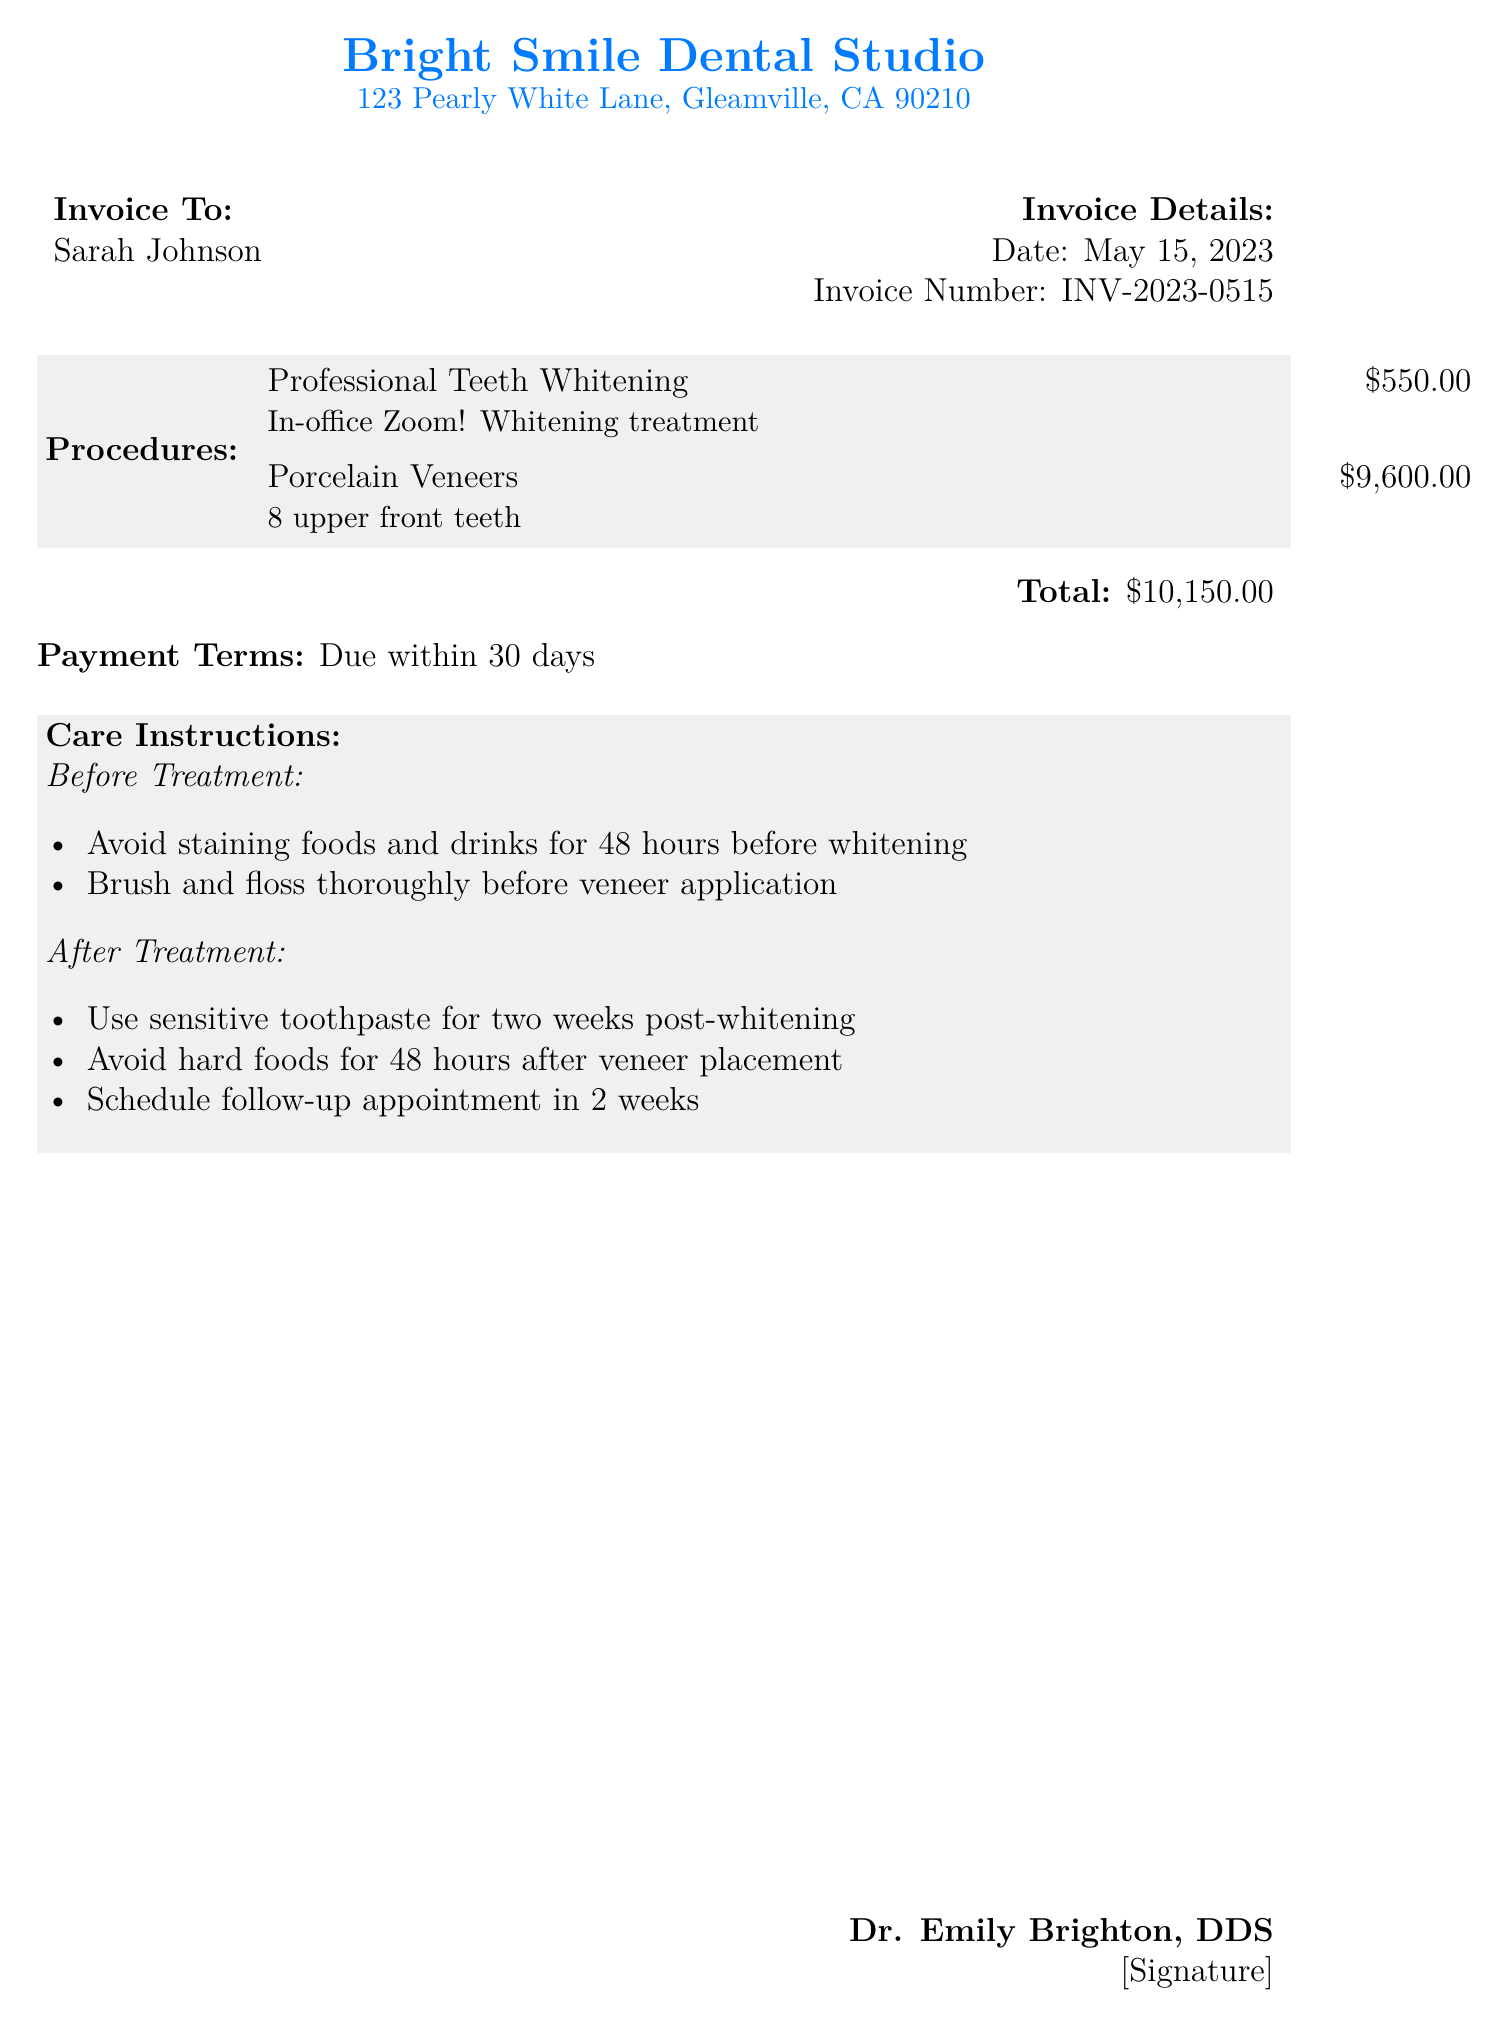What is the date of the invoice? The date of the invoice is listed in the document under Invoice Details as May 15, 2023.
Answer: May 15, 2023 What is the invoice number? The invoice number is found in the Invoice Details section, which is INV-2023-0515.
Answer: INV-2023-0515 How much does the Professional Teeth Whitening cost? The cost of Professional Teeth Whitening can be found in the Procedures section, which states it costs $550.00.
Answer: $550.00 What is the total amount due on the bill? The total amount due is calculated as the sum of all charges, which is specified in the document as $10,150.00.
Answer: $10,150.00 What should you avoid for 48 hours before whitening? This information is provided in the Care Instructions under Before Treatment, stating to avoid staining foods and drinks.
Answer: Staining foods and drinks How many upper front teeth are covered by the porcelain veneers? The document specifies in the Procedures section that 8 upper front teeth are covered by the porcelain veneers.
Answer: 8 What toothpaste should be used two weeks post-whitening? The After Treatment instructions mention using sensitive toothpaste after the treatment.
Answer: Sensitive toothpaste When is the follow-up appointment suggested? The document indicates in the After Treatment section that a follow-up appointment should be scheduled in 2 weeks.
Answer: In 2 weeks What is the payment term for this invoice? The payment terms are stated at the end of the document, specifying that payment is due within 30 days.
Answer: Due within 30 days 